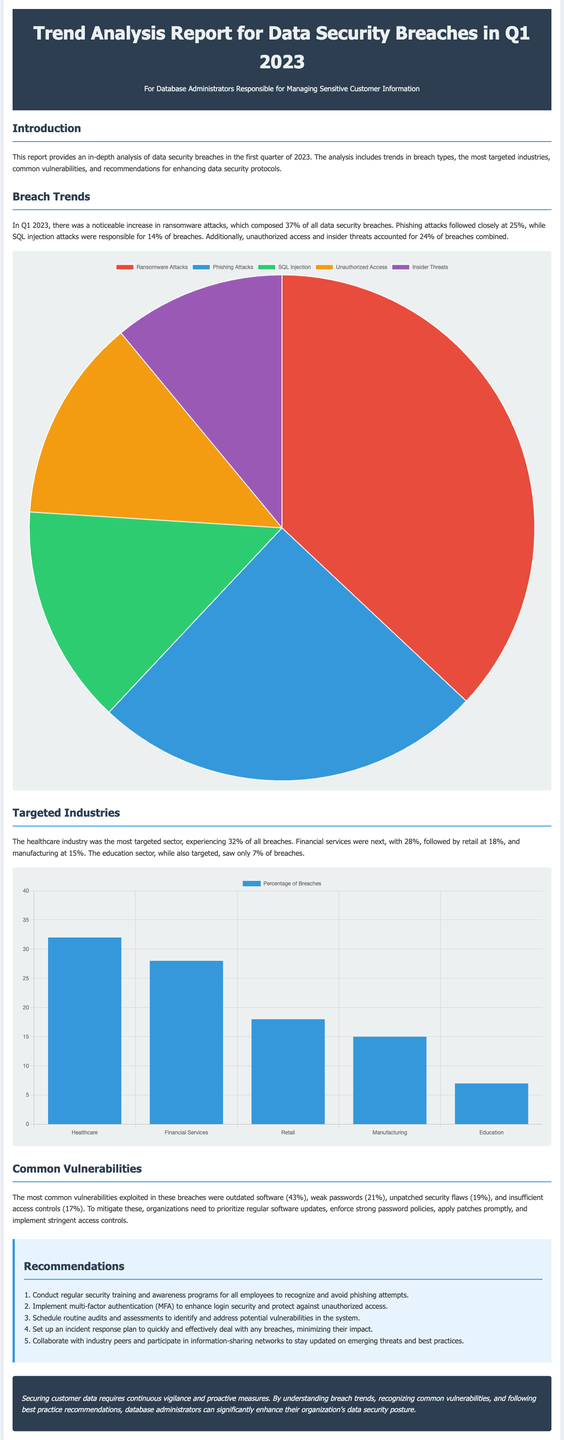What percentage of breaches were ransomware attacks? Ransomware attacks composed 37% of all data security breaches in Q1 2023, as stated in the report.
Answer: 37% Which industry experienced the highest percentage of breaches? The healthcare industry was the most targeted sector, experiencing 32% of all breaches.
Answer: Healthcare What was the second most common type of attack in Q1 2023? Phishing attacks accounted for 25%, making it the second most common type of attack.
Answer: Phishing How much percentage of breaches were due to weak passwords? Weak passwords were responsible for 21% of the breaches as per the vulnerability section of the report.
Answer: 21% What is one recommended action to enhance data security? The document suggests various recommendations, one being to conduct regular security training and awareness programs for all employees.
Answer: Conduct regular training 